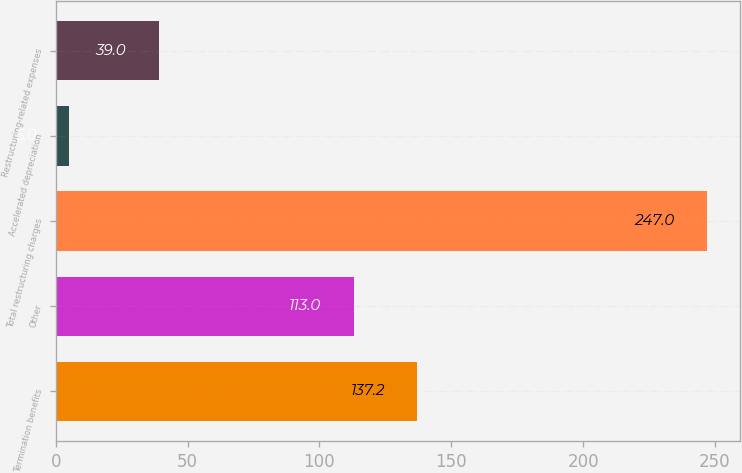Convert chart. <chart><loc_0><loc_0><loc_500><loc_500><bar_chart><fcel>Termination benefits<fcel>Other<fcel>Total restructuring charges<fcel>Accelerated depreciation<fcel>Restructuring-related expenses<nl><fcel>137.2<fcel>113<fcel>247<fcel>5<fcel>39<nl></chart> 